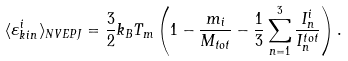<formula> <loc_0><loc_0><loc_500><loc_500>\langle \varepsilon _ { k i n } ^ { i } \rangle _ { N V E { P J } } = \frac { 3 } { 2 } k _ { B } T _ { m } \left ( 1 - \frac { m _ { i } } { M _ { t o t } } - \frac { 1 } { 3 } \sum _ { n = 1 } ^ { 3 } \frac { I _ { n } ^ { i } } { I _ { n } ^ { t o t } } \right ) .</formula> 